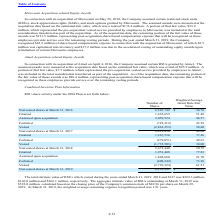According to Microchip Technology's financial document, What was the total intrinsic value of RSUs which vested during 2019? According to the financial document, 229.3 (in millions). The relevant text states: "he years ended March 31, 2019, 2018 and 2017 was $229.3 million,..." Also, What was the number of granted shares in 2016? According to the financial document, 1,635,655. The relevant text states: "Granted 1,635,655 51.46..." Also, What was the Weighted Average Grant Date Fair Value for nonvested shares at March 31, 2017? According to the financial document, 42.06. The relevant text states: "Nonvested shares at March 31, 2017 6,419,456 42.06..." Also, can you calculate: What was the change in the weighted average grant date fair value of nonvested shares between 2016 and 2017? Based on the calculation: 42.06-36.76, the result is 5.3. This is based on the information: "Nonvested shares at March 31, 2016 6,307,742 $ 36.76 Nonvested shares at March 31, 2017 6,419,456 42.06..." The key data points involved are: 36.76, 42.06. Also, can you calculate: What was the change in the number of vested shares between 2017 and 2018? Based on the calculation: -2,729,324-(-1,735,501), the result is -993823. This is based on the information: "Vested (1,735,501) 38.00 Vested (2,729,324) 61.51..." The key data points involved are: 1,735,501, 2,729,324. Also, can you calculate: What was the percentage change in the number of nonvested shares between 2018 and 2019? To answer this question, I need to perform calculations using the financial data. The calculation is: (6,291,962-5,672,440)/5,672,440, which equals 10.92 (percentage). This is based on the information: "Nonvested shares at March 31, 2018 5,672,440 50.79 Nonvested shares at March 31, 2019 6,291,962 $ 64.81..." The key data points involved are: 5,672,440, 6,291,962. 